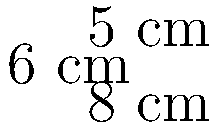As a life coach for healthcare professionals, you want to recommend a stress-relief cube for your clients. The cube has dimensions of 8 cm x 6 cm x 5 cm. Calculate the volume of this stress-relief cube to determine its suitability for your clients' workspace. To calculate the volume of a rectangular prism (in this case, our stress-relief cube), we use the formula:

$$V = l \times w \times h$$

Where:
$V$ = volume
$l$ = length
$w$ = width
$h$ = height

Given dimensions:
Length ($l$) = 8 cm
Width ($w$) = 6 cm
Height ($h$) = 5 cm

Substituting these values into the formula:

$$V = 8 \text{ cm} \times 6 \text{ cm} \times 5 \text{ cm}$$

$$V = 240 \text{ cm}^3$$

Therefore, the volume of the stress-relief cube is 240 cubic centimeters.
Answer: 240 cm³ 